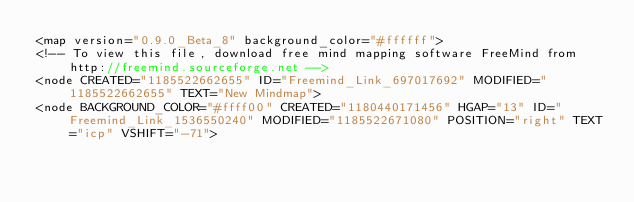<code> <loc_0><loc_0><loc_500><loc_500><_ObjectiveC_><map version="0.9.0_Beta_8" background_color="#ffffff">
<!-- To view this file, download free mind mapping software FreeMind from http://freemind.sourceforge.net -->
<node CREATED="1185522662655" ID="Freemind_Link_697017692" MODIFIED="1185522662655" TEXT="New Mindmap">
<node BACKGROUND_COLOR="#ffff00" CREATED="1180440171456" HGAP="13" ID="Freemind_Link_1536550240" MODIFIED="1185522671080" POSITION="right" TEXT="icp" VSHIFT="-71"></code> 